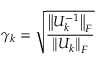Convert formula to latex. <formula><loc_0><loc_0><loc_500><loc_500>\gamma _ { k } = { \sqrt { \frac { \left \| U _ { k } ^ { - 1 } \right \| _ { F } } { \left \| U _ { k } \right \| _ { F } } } }</formula> 